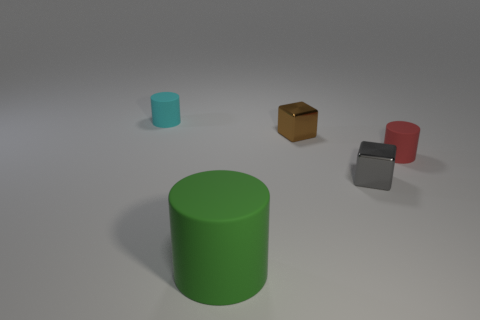Add 1 big gray cubes. How many objects exist? 6 Subtract all tiny rubber cylinders. How many cylinders are left? 1 Subtract all cylinders. How many objects are left? 2 Subtract all brown cylinders. Subtract all green blocks. How many cylinders are left? 3 Add 1 red rubber objects. How many red rubber objects exist? 2 Subtract 1 red cylinders. How many objects are left? 4 Subtract all large cylinders. Subtract all brown things. How many objects are left? 3 Add 3 small red matte cylinders. How many small red matte cylinders are left? 4 